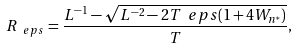<formula> <loc_0><loc_0><loc_500><loc_500>R _ { \ e p s } = \frac { L ^ { - 1 } - \sqrt { L ^ { - 2 } - 2 T \ e p s ( 1 + 4 W _ { n ^ { * } } ) } } { T } ,</formula> 